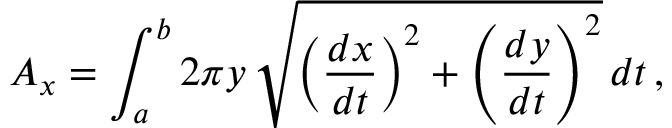<formula> <loc_0><loc_0><loc_500><loc_500>A _ { x } = \int _ { a } ^ { b } 2 \pi y \, { \sqrt { \left ( { \frac { d x } { d t } } \right ) ^ { 2 } + \left ( { \frac { d y } { d t } } \right ) ^ { 2 } } } \, d t \, ,</formula> 